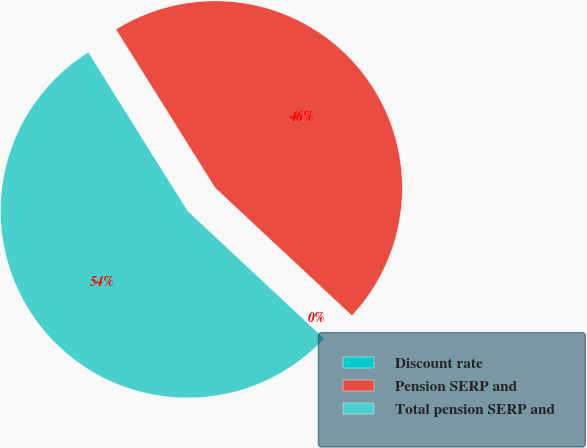Convert chart to OTSL. <chart><loc_0><loc_0><loc_500><loc_500><pie_chart><fcel>Discount rate<fcel>Pension SERP and<fcel>Total pension SERP and<nl><fcel>0.01%<fcel>45.86%<fcel>54.13%<nl></chart> 